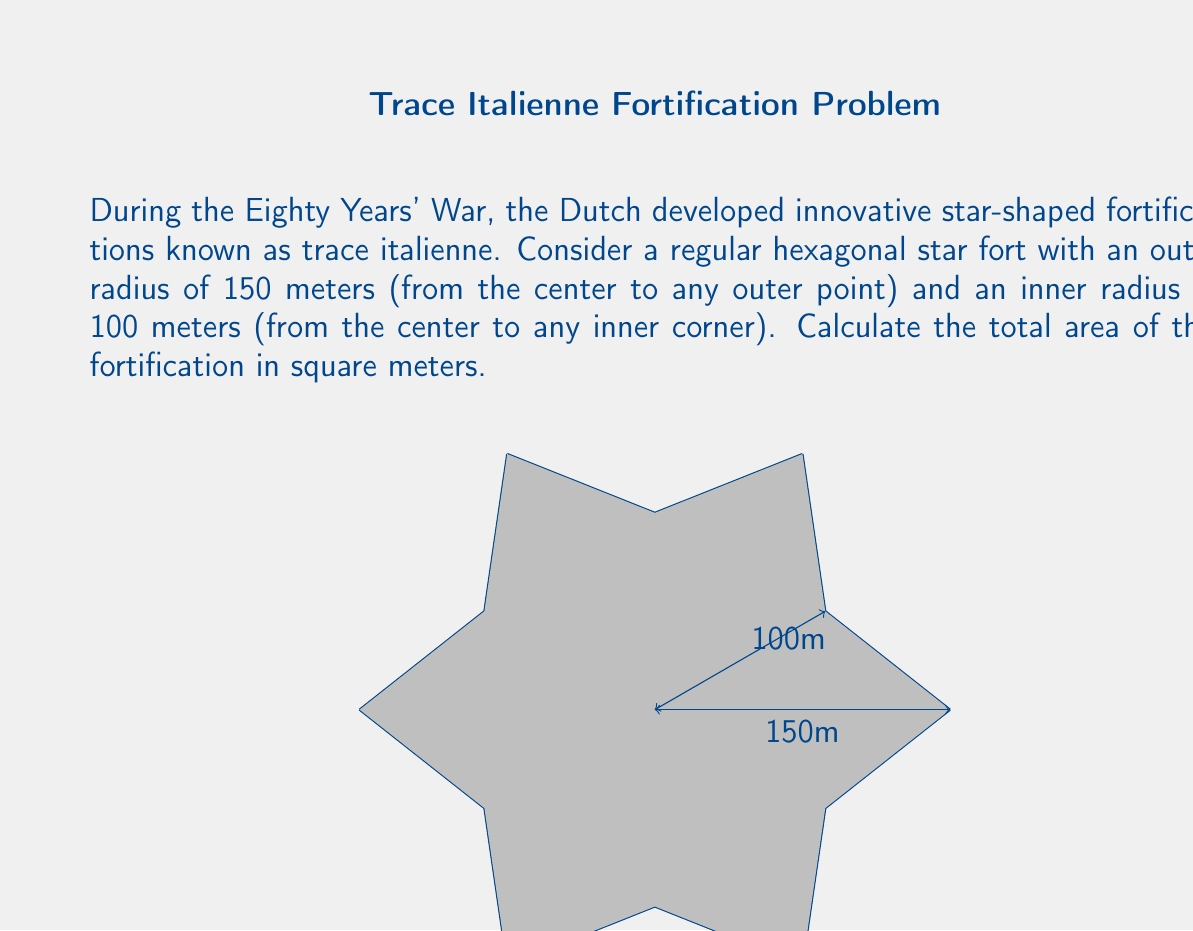Provide a solution to this math problem. To calculate the area of this star-shaped fortification, we can break it down into 12 congruent triangles and use the formula for the area of a triangle.

1) First, let's consider one of these triangles. It has a base of $150 - 100 = 50$ meters (the difference between the outer and inner radii) and a height that we need to calculate.

2) To find the height, we can use the Pythagorean theorem:
   $$ h^2 + 25^2 = 150^2 $$
   $$ h^2 = 150^2 - 25^2 = 22,500 - 625 = 21,875 $$
   $$ h = \sqrt{21,875} \approx 147.90 \text{ meters} $$

3) Now we can calculate the area of one triangle:
   $$ A_{\text{triangle}} = \frac{1}{2} \times \text{base} \times \text{height} = \frac{1}{2} \times 50 \times 147.90 = 3,697.5 \text{ sq meters} $$

4) Since there are 12 such triangles in the star, the total area is:
   $$ A_{\text{total}} = 12 \times A_{\text{triangle}} = 12 \times 3,697.5 = 44,370 \text{ sq meters} $$

Therefore, the total area of the star-shaped fortification is approximately 44,370 square meters.
Answer: $44,370 \text{ square meters}$ 